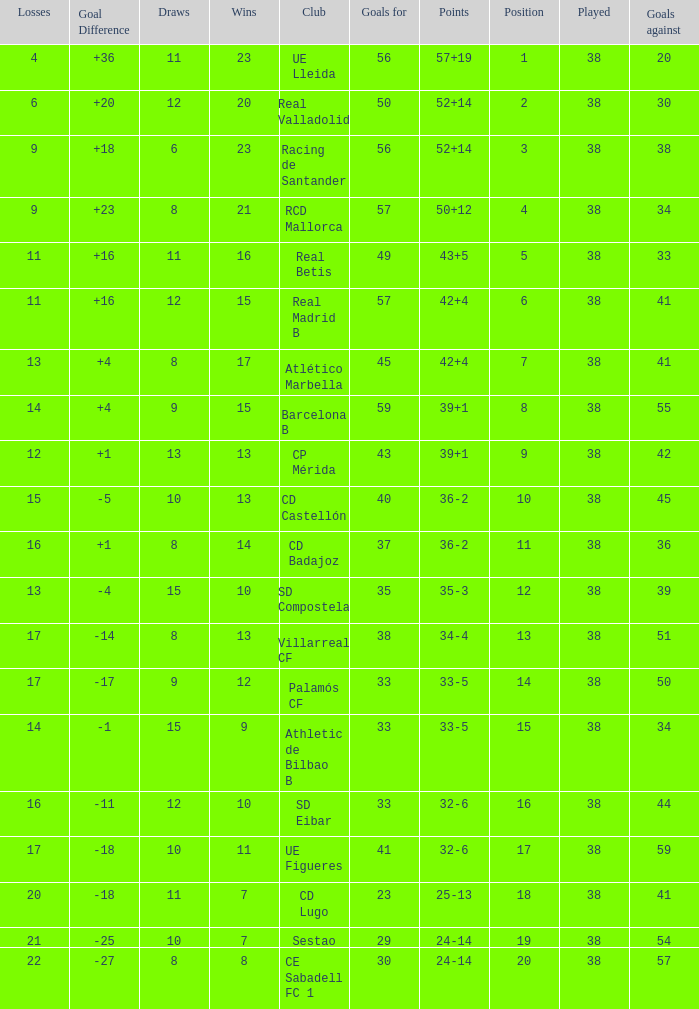What is the highest number played with a goal difference less than -27? None. 